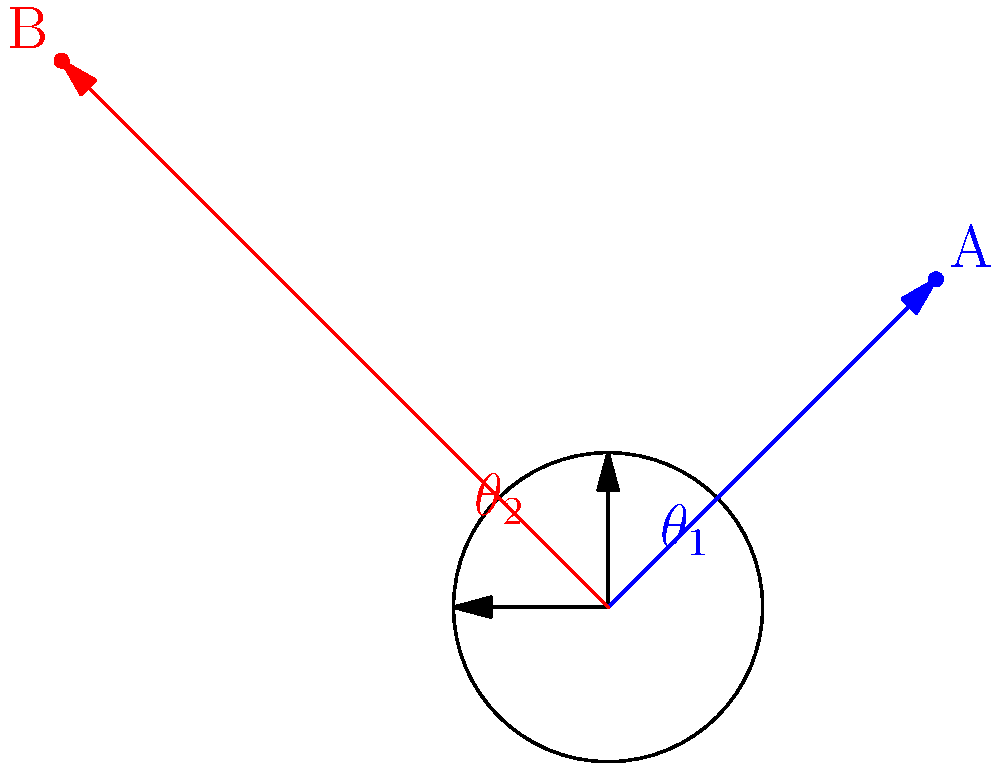In a polar coordinate system, point A represents your current job role, and point B represents your desired job role. Given that A has coordinates $(r_1, \theta_1) = (3, \pi/4)$ and B has coordinates $(r_2, \theta_2) = (5, 3\pi/4)$, calculate the distance between these two points to quantify the gap between your current and desired positions. To calculate the distance between two points in polar coordinates, we can use the polar form of the distance formula:

$$d = \sqrt{r_1^2 + r_2^2 - 2r_1r_2\cos(\theta_2 - \theta_1)}$$

Let's substitute the given values:
$r_1 = 3$, $r_2 = 5$, $\theta_1 = \pi/4$, $\theta_2 = 3\pi/4$

Step 1: Calculate $\theta_2 - \theta_1$
$$\theta_2 - \theta_1 = 3\pi/4 - \pi/4 = \pi/2$$

Step 2: Calculate $\cos(\theta_2 - \theta_1)$
$$\cos(\pi/2) = 0$$

Step 3: Substitute all values into the formula
$$d = \sqrt{3^2 + 5^2 - 2(3)(5)\cos(\pi/2)}$$
$$d = \sqrt{9 + 25 - 2(3)(5)(0)}$$
$$d = \sqrt{9 + 25}$$
$$d = \sqrt{34}$$

Step 4: Simplify the result
$$d = \sqrt{34} \approx 5.83$$

Therefore, the distance between your current job role (point A) and your desired job role (point B) is approximately 5.83 units in the polar coordinate system.
Answer: $\sqrt{34}$ units (or approximately 5.83 units) 